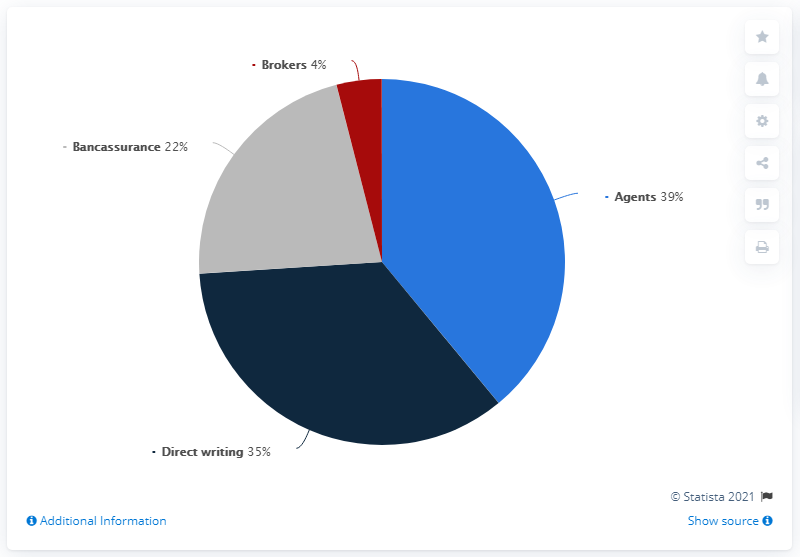List a handful of essential elements in this visual. The sum of segments that exceed 30 is 74. The color of the segment with a value of 22% is gray. 